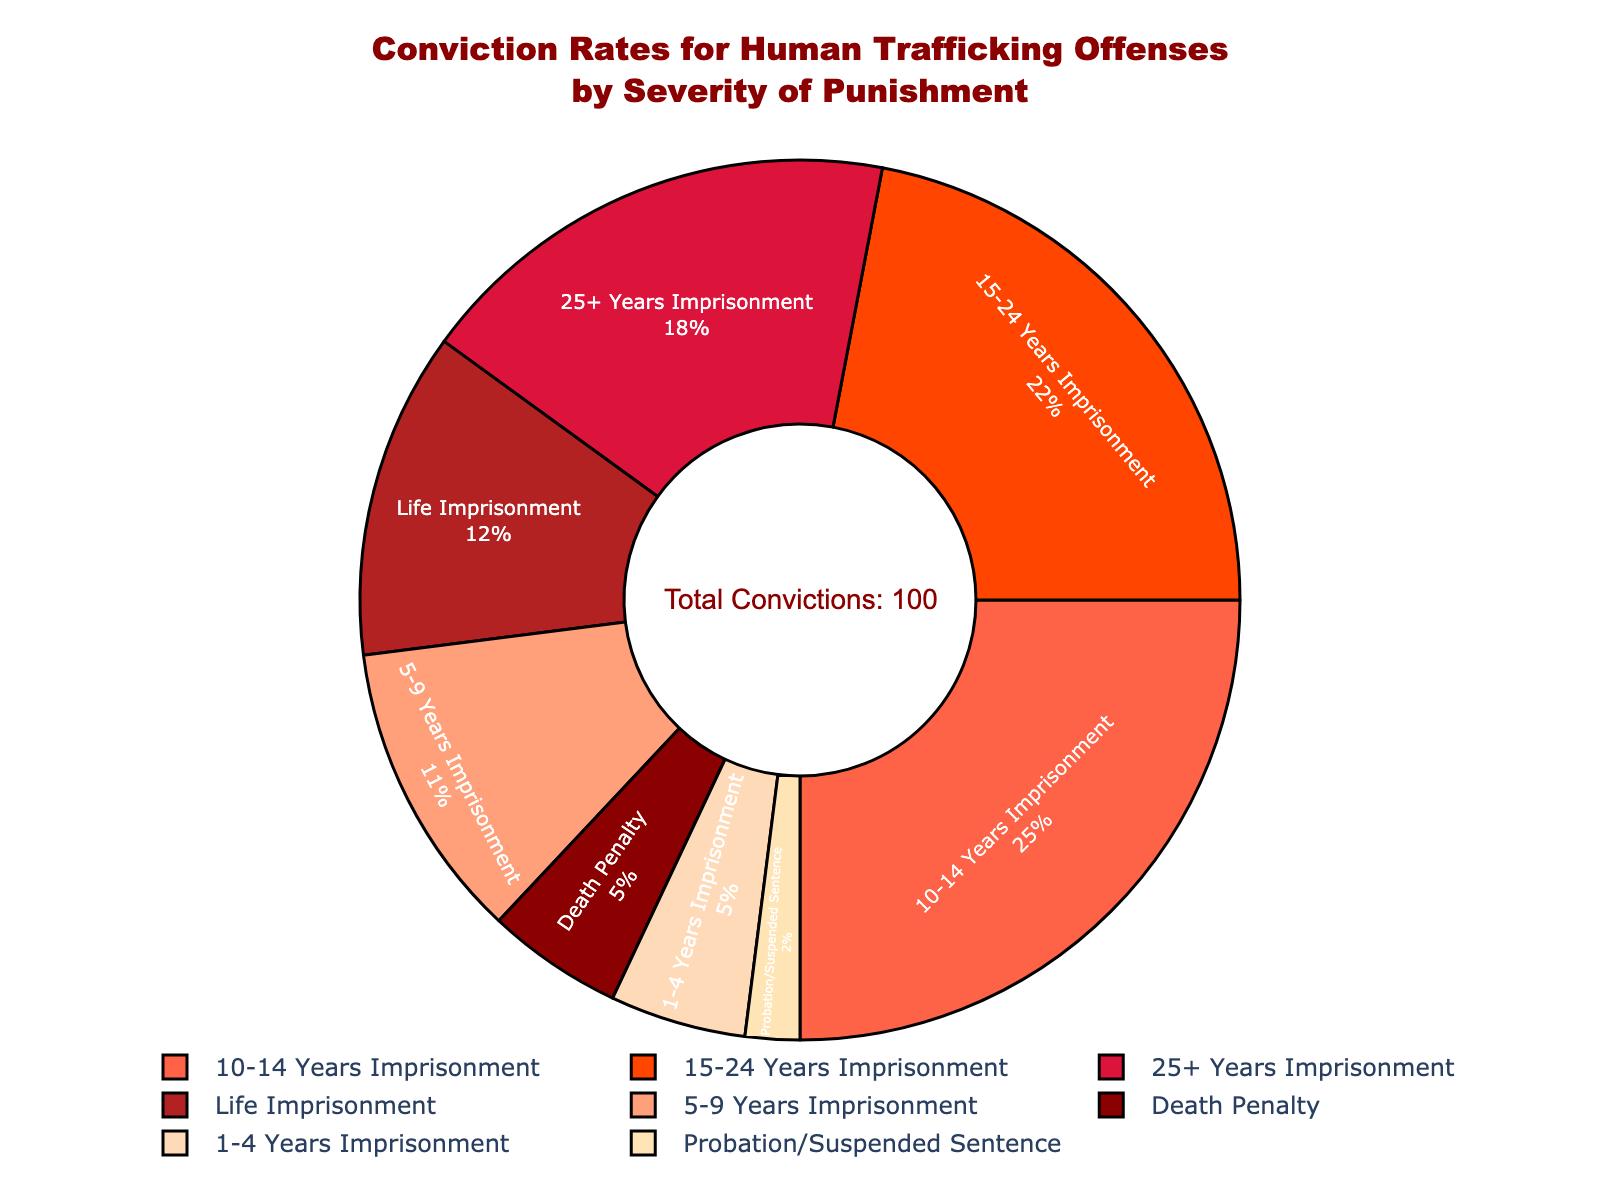What percentage of convictions result in death penalty? The pie chart indicates that the section labeled "Death Penalty" represents 5% of the total convictions.
Answer: 5% Which category has the highest conviction rate? By visually inspecting the pie chart, the segment labeled "10-14 Years Imprisonment" is the largest, indicating the highest conviction rate.
Answer: 10-14 Years Imprisonment What is the combined percentage of convictions for life imprisonment and the death penalty? Adding the percentages for "Life Imprisonment" (12%) and "Death Penalty" (5%) yields 17%.
Answer: 17% Between "5-9 Years Imprisonment" and "25+ Years Imprisonment," which has a higher conviction rate? The pie chart shows that "25+ Years Imprisonment" has 18% while "5-9 Years Imprisonment" has 11%, making the former higher.
Answer: 25+ Years Imprisonment How does the conviction rate for "Probation/Suspended Sentence" compare to "1-4 Years Imprisonment"? The pie chart reveals that "Probation/Suspended Sentence" has 2% while "1-4 Years Imprisonment" has 5%, so the former is smaller.
Answer: Probation/Suspended Sentence is smaller If you combine the conviction rates of punishments less than 10 years (1-4 years, 5-9 years, Probation/Suspended Sentence), what percentage do you get? Adding "1-4 Years Imprisonment" (5%), "5-9 Years Imprisonment" (11%), and "Probation/Suspended Sentence" (2%) gives a total of 18%.
Answer: 18% Which section represents the smallest segment in the pie chart? The smallest segment is clearly marked "Probation/Suspended Sentence" at 2%.
Answer: Probation/Suspended Sentence How many percentage points higher is the conviction rate for "10-14 Years Imprisonment" compared to "Life Imprisonment"? "10-14 Years Imprisonment" is 25% and "Life Imprisonment" is 12%, so the difference is 25 - 12 = 13 percentage points.
Answer: 13 What is the sum of conviction rates for all categories involving imprisonment? Adding all the imprisonment categories: "Life Imprisonment" (12%) + "25+ Years Imprisonment" (18%) + "15-24 Years Imprisonment" (22%) + "10-14 Years Imprisonment" (25%) + "5-9 Years Imprisonment" (11%) + "1-4 Years Imprisonment" (5%) equals 93%.
Answer: 93% What share of total convictions does not involve imprisonment? Summing the percentages for non-imprisonment categories: "Death Penalty" (5%) + "Probation/Suspended Sentence" (2%) equals 7%.
Answer: 7% 